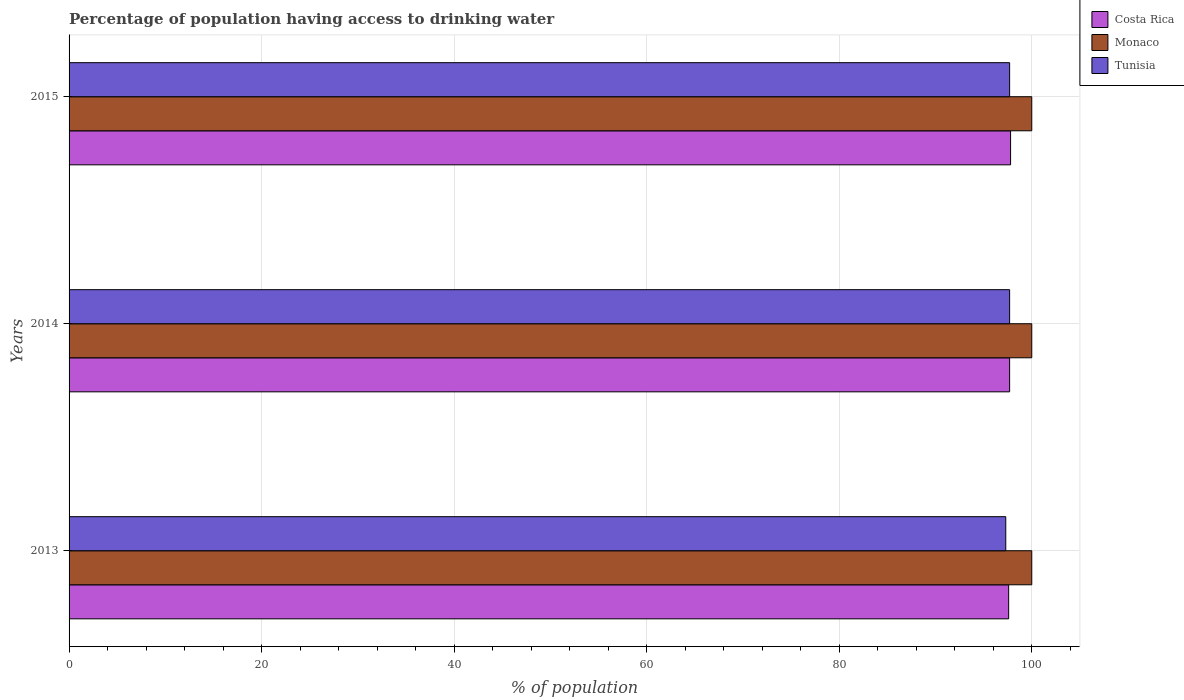How many different coloured bars are there?
Keep it short and to the point. 3. How many groups of bars are there?
Your answer should be very brief. 3. Are the number of bars per tick equal to the number of legend labels?
Give a very brief answer. Yes. Are the number of bars on each tick of the Y-axis equal?
Your answer should be very brief. Yes. How many bars are there on the 3rd tick from the top?
Your answer should be compact. 3. In how many cases, is the number of bars for a given year not equal to the number of legend labels?
Offer a terse response. 0. What is the percentage of population having access to drinking water in Monaco in 2014?
Your response must be concise. 100. Across all years, what is the maximum percentage of population having access to drinking water in Tunisia?
Your answer should be compact. 97.7. Across all years, what is the minimum percentage of population having access to drinking water in Monaco?
Ensure brevity in your answer.  100. In which year was the percentage of population having access to drinking water in Costa Rica maximum?
Offer a very short reply. 2015. What is the total percentage of population having access to drinking water in Tunisia in the graph?
Offer a terse response. 292.7. What is the difference between the percentage of population having access to drinking water in Tunisia in 2013 and that in 2014?
Your response must be concise. -0.4. What is the difference between the percentage of population having access to drinking water in Monaco in 2013 and the percentage of population having access to drinking water in Costa Rica in 2015?
Provide a short and direct response. 2.2. What is the average percentage of population having access to drinking water in Monaco per year?
Offer a terse response. 100. In the year 2015, what is the difference between the percentage of population having access to drinking water in Monaco and percentage of population having access to drinking water in Tunisia?
Make the answer very short. 2.3. What is the ratio of the percentage of population having access to drinking water in Tunisia in 2013 to that in 2015?
Give a very brief answer. 1. Is the difference between the percentage of population having access to drinking water in Monaco in 2013 and 2014 greater than the difference between the percentage of population having access to drinking water in Tunisia in 2013 and 2014?
Provide a short and direct response. Yes. What is the difference between the highest and the second highest percentage of population having access to drinking water in Monaco?
Keep it short and to the point. 0. What is the difference between the highest and the lowest percentage of population having access to drinking water in Costa Rica?
Ensure brevity in your answer.  0.2. Is the sum of the percentage of population having access to drinking water in Tunisia in 2013 and 2015 greater than the maximum percentage of population having access to drinking water in Monaco across all years?
Provide a succinct answer. Yes. What does the 1st bar from the top in 2015 represents?
Ensure brevity in your answer.  Tunisia. What does the 2nd bar from the bottom in 2014 represents?
Make the answer very short. Monaco. Are all the bars in the graph horizontal?
Offer a terse response. Yes. How many years are there in the graph?
Your answer should be very brief. 3. Does the graph contain any zero values?
Keep it short and to the point. No. Does the graph contain grids?
Provide a succinct answer. Yes. How are the legend labels stacked?
Keep it short and to the point. Vertical. What is the title of the graph?
Keep it short and to the point. Percentage of population having access to drinking water. What is the label or title of the X-axis?
Your answer should be compact. % of population. What is the % of population of Costa Rica in 2013?
Your answer should be very brief. 97.6. What is the % of population of Monaco in 2013?
Ensure brevity in your answer.  100. What is the % of population in Tunisia in 2013?
Your answer should be compact. 97.3. What is the % of population in Costa Rica in 2014?
Make the answer very short. 97.7. What is the % of population of Tunisia in 2014?
Provide a short and direct response. 97.7. What is the % of population of Costa Rica in 2015?
Make the answer very short. 97.8. What is the % of population in Tunisia in 2015?
Keep it short and to the point. 97.7. Across all years, what is the maximum % of population in Costa Rica?
Offer a terse response. 97.8. Across all years, what is the maximum % of population in Tunisia?
Make the answer very short. 97.7. Across all years, what is the minimum % of population of Costa Rica?
Offer a very short reply. 97.6. Across all years, what is the minimum % of population in Monaco?
Your response must be concise. 100. Across all years, what is the minimum % of population in Tunisia?
Your response must be concise. 97.3. What is the total % of population of Costa Rica in the graph?
Make the answer very short. 293.1. What is the total % of population in Monaco in the graph?
Give a very brief answer. 300. What is the total % of population in Tunisia in the graph?
Your answer should be compact. 292.7. What is the difference between the % of population of Costa Rica in 2013 and that in 2014?
Your response must be concise. -0.1. What is the difference between the % of population of Monaco in 2013 and that in 2014?
Offer a very short reply. 0. What is the difference between the % of population of Tunisia in 2013 and that in 2014?
Your answer should be compact. -0.4. What is the difference between the % of population of Tunisia in 2014 and that in 2015?
Provide a short and direct response. 0. What is the difference between the % of population in Costa Rica in 2013 and the % of population in Tunisia in 2014?
Ensure brevity in your answer.  -0.1. What is the difference between the % of population in Costa Rica in 2013 and the % of population in Tunisia in 2015?
Provide a short and direct response. -0.1. What is the difference between the % of population of Monaco in 2013 and the % of population of Tunisia in 2015?
Your response must be concise. 2.3. What is the difference between the % of population in Costa Rica in 2014 and the % of population in Monaco in 2015?
Provide a succinct answer. -2.3. What is the average % of population in Costa Rica per year?
Your answer should be compact. 97.7. What is the average % of population in Tunisia per year?
Your answer should be compact. 97.57. In the year 2013, what is the difference between the % of population in Costa Rica and % of population in Tunisia?
Your answer should be very brief. 0.3. In the year 2013, what is the difference between the % of population in Monaco and % of population in Tunisia?
Your response must be concise. 2.7. In the year 2014, what is the difference between the % of population in Costa Rica and % of population in Monaco?
Your answer should be compact. -2.3. In the year 2014, what is the difference between the % of population in Monaco and % of population in Tunisia?
Keep it short and to the point. 2.3. In the year 2015, what is the difference between the % of population in Monaco and % of population in Tunisia?
Your response must be concise. 2.3. What is the ratio of the % of population in Costa Rica in 2013 to that in 2014?
Your answer should be very brief. 1. What is the ratio of the % of population in Tunisia in 2013 to that in 2014?
Provide a short and direct response. 1. What is the ratio of the % of population in Monaco in 2013 to that in 2015?
Make the answer very short. 1. What is the ratio of the % of population of Tunisia in 2013 to that in 2015?
Offer a terse response. 1. What is the ratio of the % of population of Monaco in 2014 to that in 2015?
Offer a terse response. 1. What is the difference between the highest and the lowest % of population in Costa Rica?
Keep it short and to the point. 0.2. What is the difference between the highest and the lowest % of population of Monaco?
Your answer should be very brief. 0. 